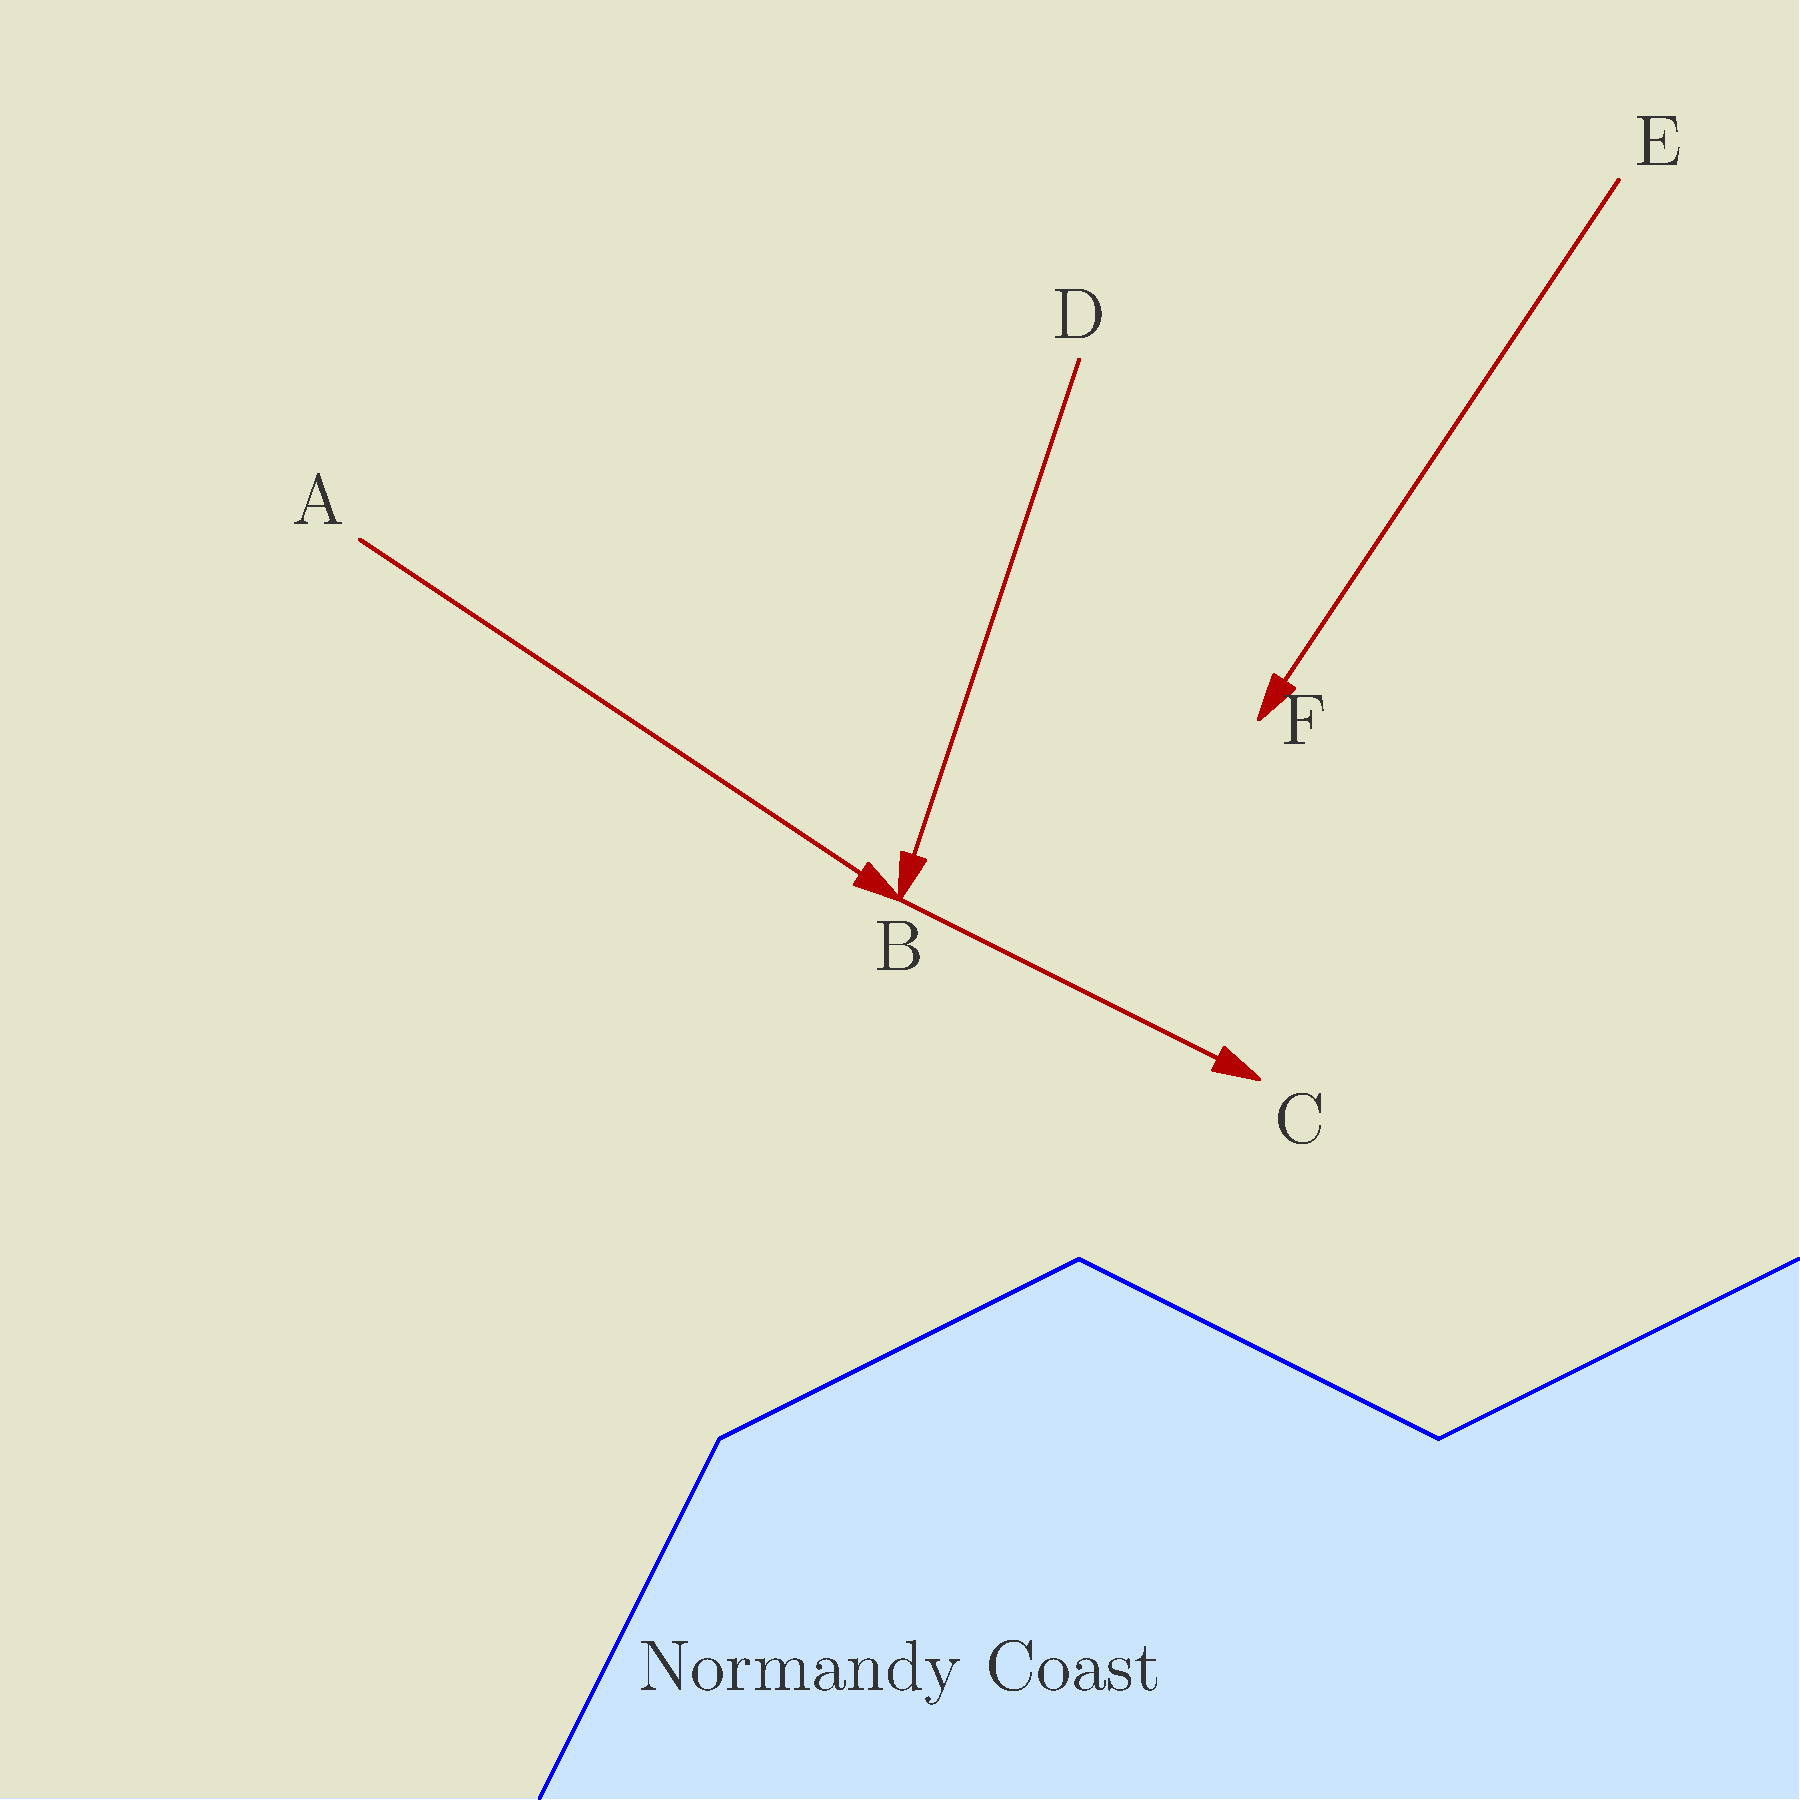Based on the map of troop movements during the Normandy invasion, which arrow represents the most strategically significant advance of Allied forces, and why? To answer this question, we need to analyze each arrow and its strategic implications:

1. Arrow A to B: This represents a movement from the inland area towards the coast. It could be a counterattack by German forces or a repositioning of Allied troops.

2. Arrow B to C: This shows a movement along the coastline, possibly securing beachheads or linking up separate landing zones.

3. Arrow D to B: Another movement from inland to the coast, similar to A to B.

4. Arrow E to F: This represents a movement from the far inland towards the coast, but not reaching it.

The most strategically significant advance is likely the arrow from B to C for the following reasons:

1. Direction: It moves along the coastline, which is crucial for connecting different landing zones and expanding the beachhead.

2. Starting point: It begins at point B, which seems to be a convergence point for other movements (A to B and D to B), suggesting it's a well-reinforced position.

3. Endpoint: It ends at point C, which is the furthest point along the coast, indicating a significant expansion of the Allied-controlled area.

4. Tactical advantage: Controlling more of the coastline would allow for easier resupply from the sea and prevent German forces from splitting the Allied landing zones.

5. Historical context: In the actual Normandy invasion, linking the individual beachheads was a crucial early objective to prevent German counterattacks from isolating and defeating each landing zone separately.

This movement likely represents the Allied forces successfully expanding their control along the coast, which was a key strategic goal in the early stages of the invasion.
Answer: Arrow B to C, representing coastal expansion and beachhead linkup. 